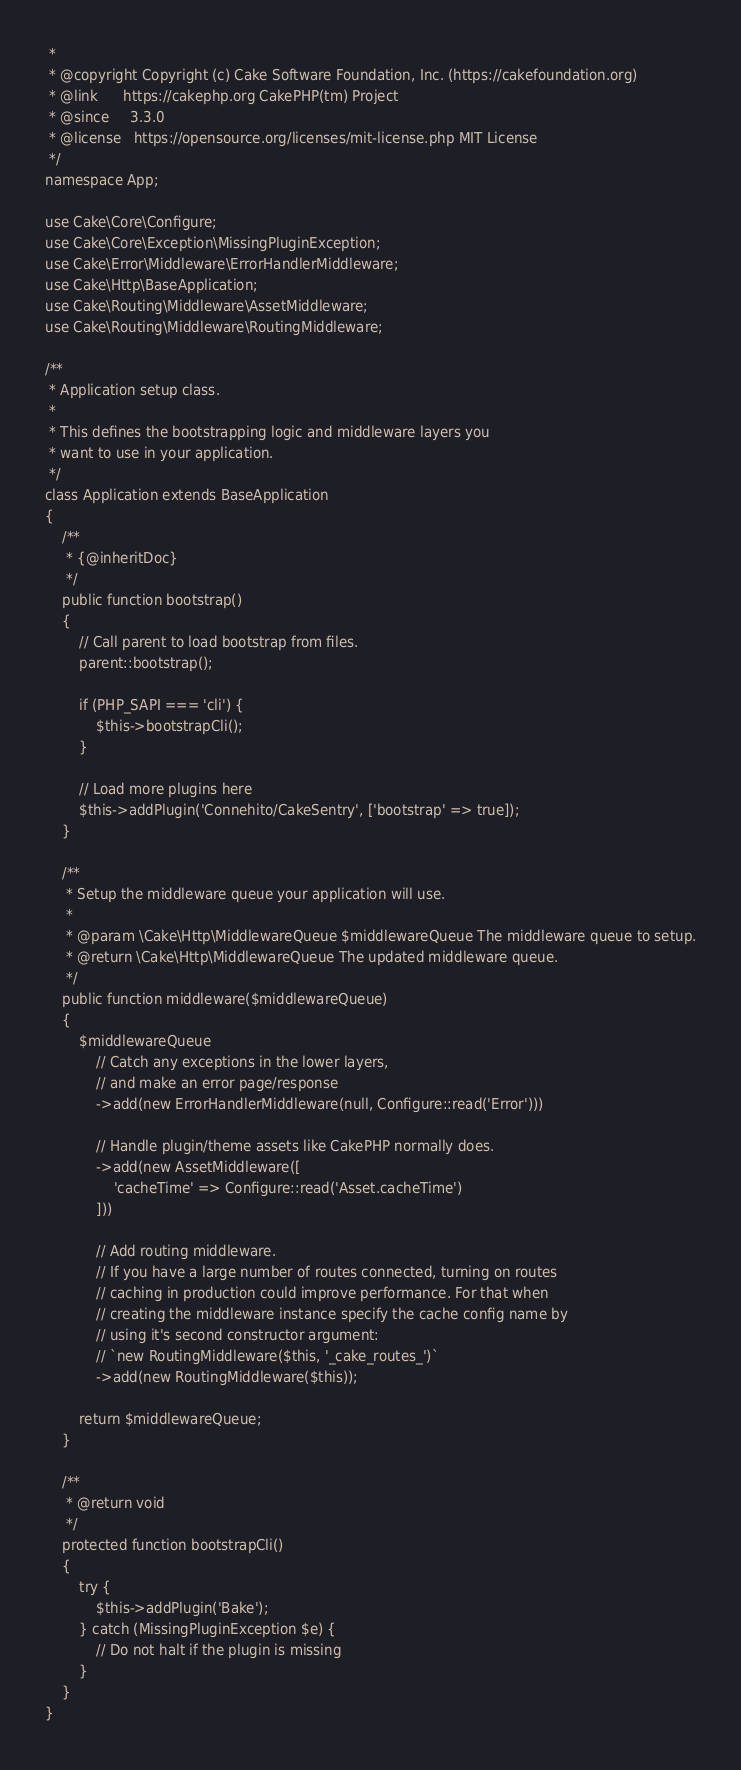<code> <loc_0><loc_0><loc_500><loc_500><_PHP_> *
 * @copyright Copyright (c) Cake Software Foundation, Inc. (https://cakefoundation.org)
 * @link      https://cakephp.org CakePHP(tm) Project
 * @since     3.3.0
 * @license   https://opensource.org/licenses/mit-license.php MIT License
 */
namespace App;

use Cake\Core\Configure;
use Cake\Core\Exception\MissingPluginException;
use Cake\Error\Middleware\ErrorHandlerMiddleware;
use Cake\Http\BaseApplication;
use Cake\Routing\Middleware\AssetMiddleware;
use Cake\Routing\Middleware\RoutingMiddleware;

/**
 * Application setup class.
 *
 * This defines the bootstrapping logic and middleware layers you
 * want to use in your application.
 */
class Application extends BaseApplication
{
    /**
     * {@inheritDoc}
     */
    public function bootstrap()
    {
        // Call parent to load bootstrap from files.
        parent::bootstrap();

        if (PHP_SAPI === 'cli') {
            $this->bootstrapCli();
        }

        // Load more plugins here
        $this->addPlugin('Connehito/CakeSentry', ['bootstrap' => true]);
    }

    /**
     * Setup the middleware queue your application will use.
     *
     * @param \Cake\Http\MiddlewareQueue $middlewareQueue The middleware queue to setup.
     * @return \Cake\Http\MiddlewareQueue The updated middleware queue.
     */
    public function middleware($middlewareQueue)
    {
        $middlewareQueue
            // Catch any exceptions in the lower layers,
            // and make an error page/response
            ->add(new ErrorHandlerMiddleware(null, Configure::read('Error')))

            // Handle plugin/theme assets like CakePHP normally does.
            ->add(new AssetMiddleware([
                'cacheTime' => Configure::read('Asset.cacheTime')
            ]))

            // Add routing middleware.
            // If you have a large number of routes connected, turning on routes
            // caching in production could improve performance. For that when
            // creating the middleware instance specify the cache config name by
            // using it's second constructor argument:
            // `new RoutingMiddleware($this, '_cake_routes_')`
            ->add(new RoutingMiddleware($this));

        return $middlewareQueue;
    }

    /**
     * @return void
     */
    protected function bootstrapCli()
    {
        try {
            $this->addPlugin('Bake');
        } catch (MissingPluginException $e) {
            // Do not halt if the plugin is missing
        }
    }
}
</code> 